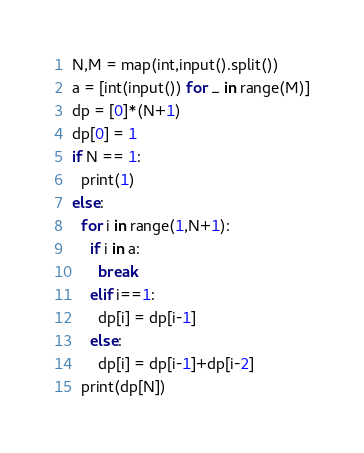<code> <loc_0><loc_0><loc_500><loc_500><_Python_>N,M = map(int,input().split())
a = [int(input()) for _ in range(M)]
dp = [0]*(N+1)
dp[0] = 1
if N == 1:
  print(1)
else:
  for i in range(1,N+1):
    if i in a:
      break
    elif i==1:
      dp[i] = dp[i-1]
    else:
      dp[i] = dp[i-1]+dp[i-2]
  print(dp[N])</code> 